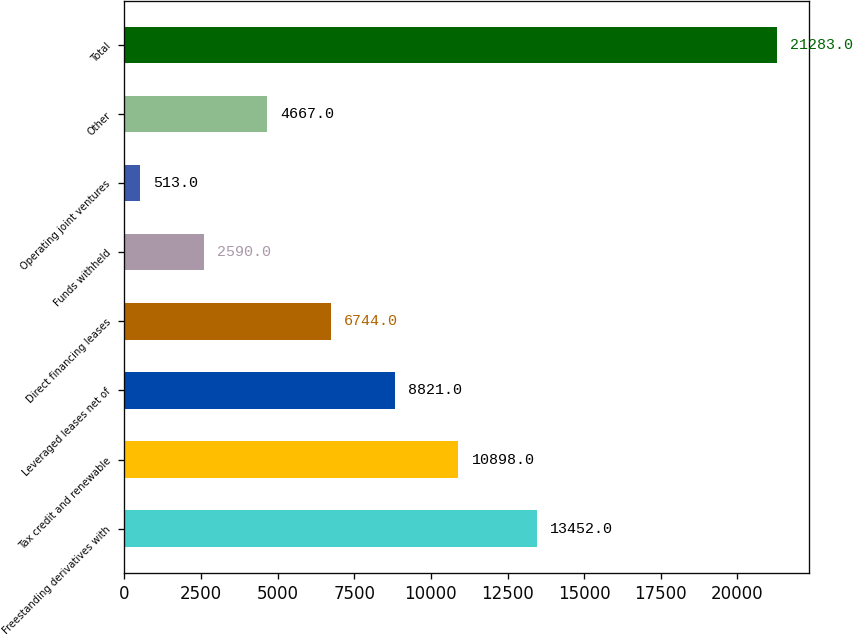Convert chart to OTSL. <chart><loc_0><loc_0><loc_500><loc_500><bar_chart><fcel>Freestanding derivatives with<fcel>Tax credit and renewable<fcel>Leveraged leases net of<fcel>Direct financing leases<fcel>Funds withheld<fcel>Operating joint ventures<fcel>Other<fcel>Total<nl><fcel>13452<fcel>10898<fcel>8821<fcel>6744<fcel>2590<fcel>513<fcel>4667<fcel>21283<nl></chart> 